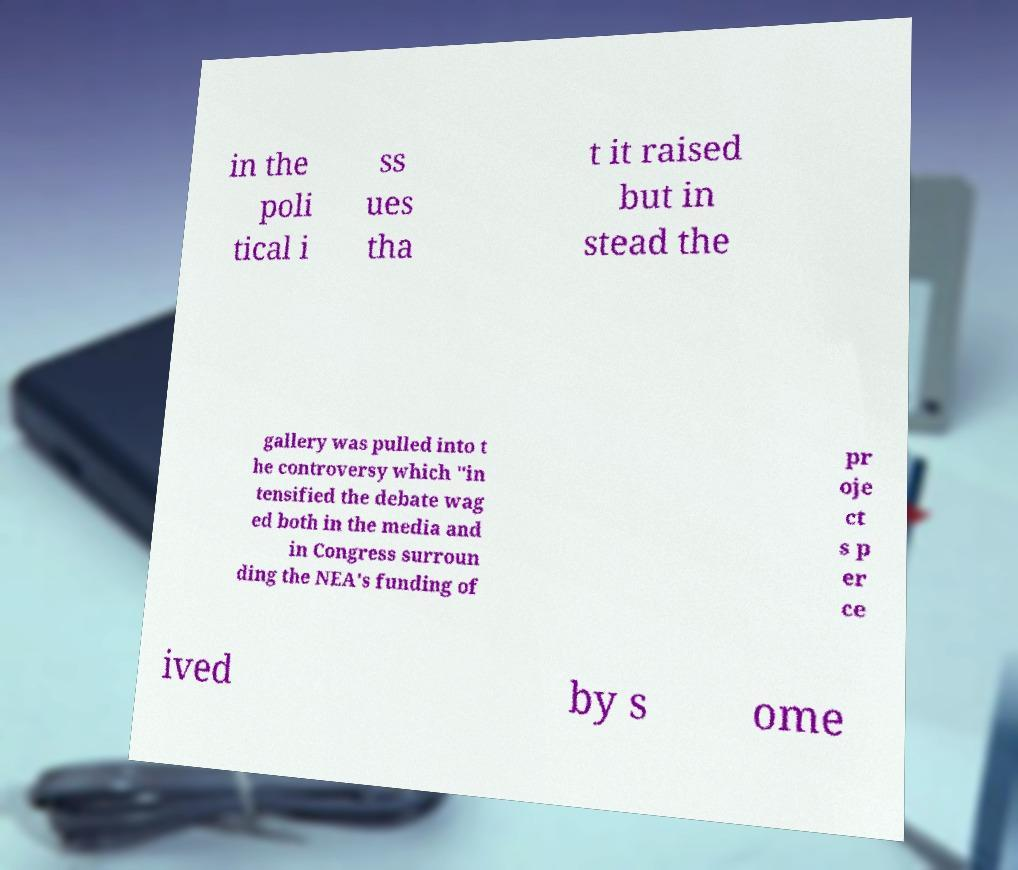Could you assist in decoding the text presented in this image and type it out clearly? in the poli tical i ss ues tha t it raised but in stead the gallery was pulled into t he controversy which "in tensified the debate wag ed both in the media and in Congress surroun ding the NEA's funding of pr oje ct s p er ce ived by s ome 